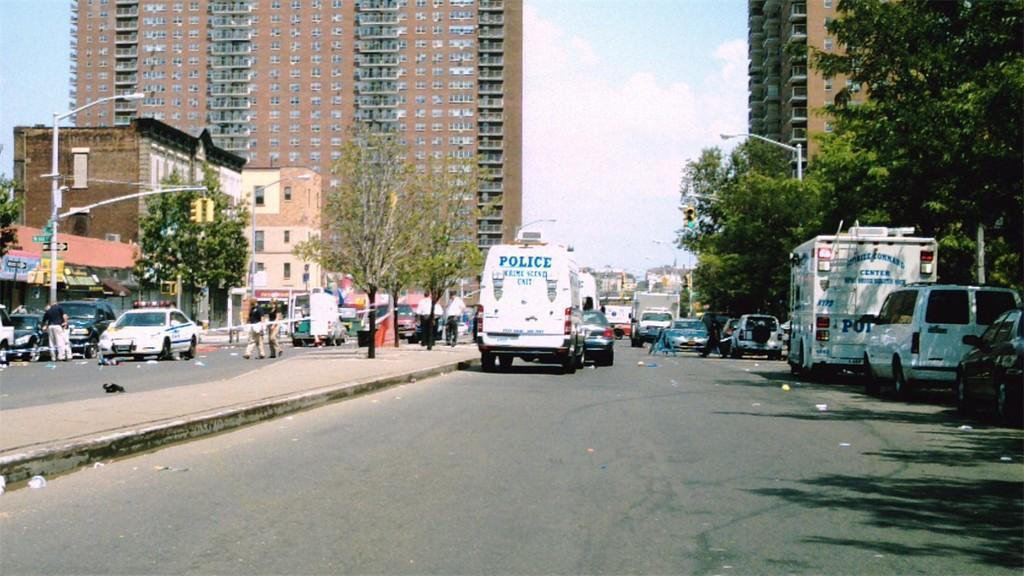Please provide a concise description of this image. In this image I can see group of people walking on the road, I can also see few vehicles. Background I can see few light poles, traffic signals, trees in green color, buildings in brown and gray color and the sky is in blue and white color. 